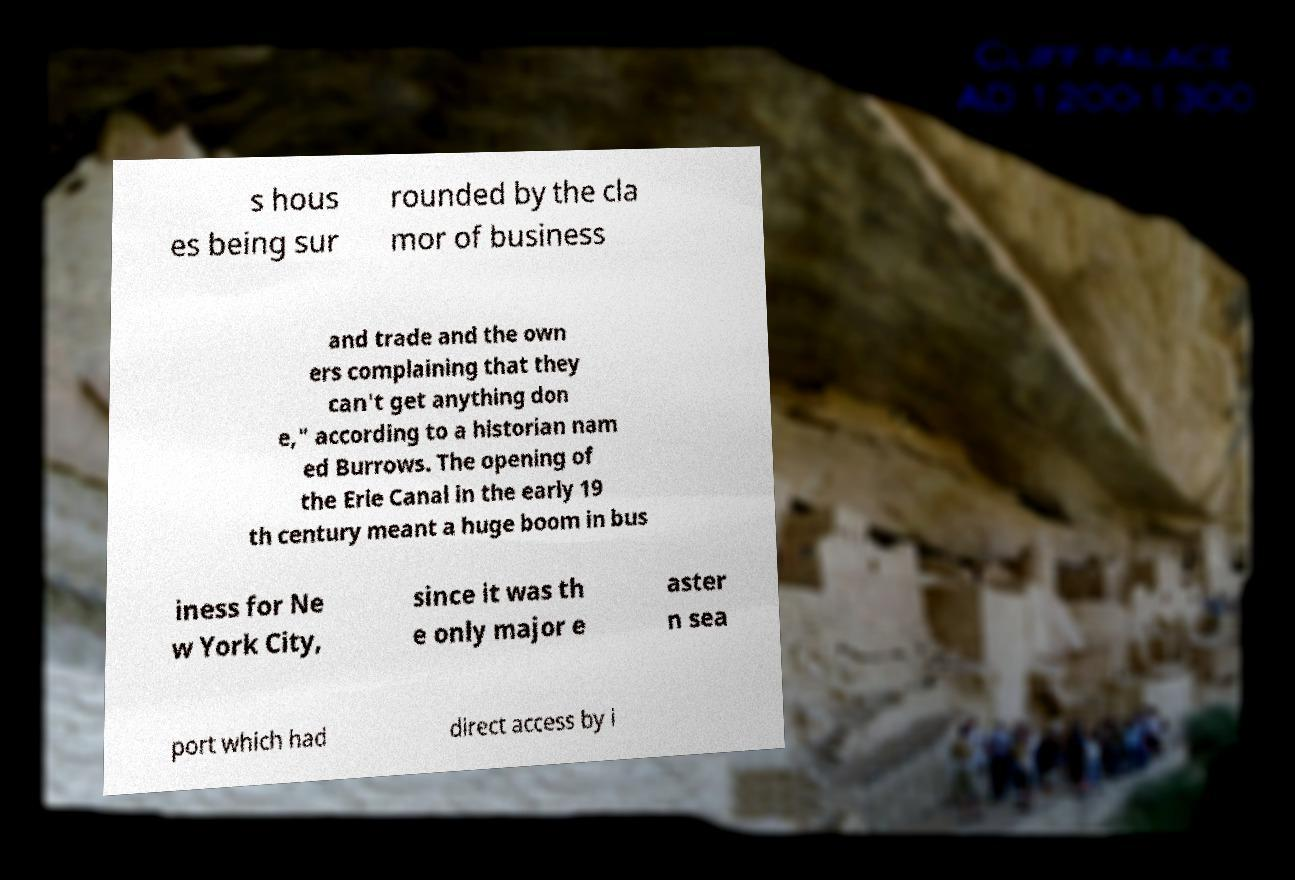Can you accurately transcribe the text from the provided image for me? s hous es being sur rounded by the cla mor of business and trade and the own ers complaining that they can't get anything don e," according to a historian nam ed Burrows. The opening of the Erie Canal in the early 19 th century meant a huge boom in bus iness for Ne w York City, since it was th e only major e aster n sea port which had direct access by i 